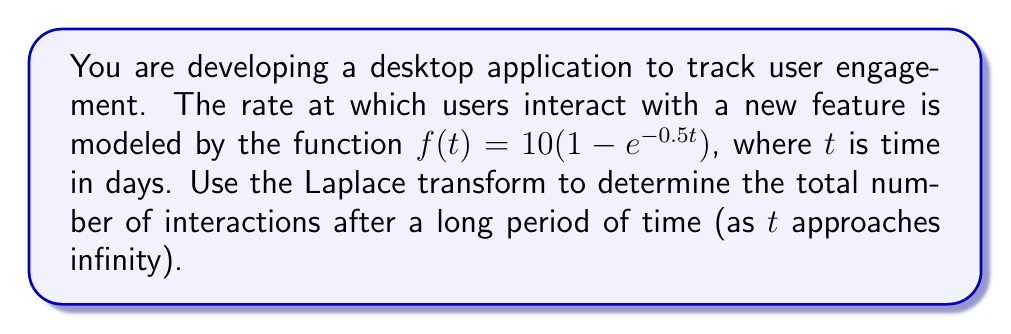Teach me how to tackle this problem. To solve this problem, we'll follow these steps:

1) First, let's recall the Laplace transform of $f(t)$:

   $\mathcal{L}\{f(t)\} = F(s) = \int_0^\infty f(t)e^{-st}dt$

2) We need to find the Laplace transform of our function:

   $f(t) = 10(1 - e^{-0.5t})$

3) We can split this into two parts:

   $\mathcal{L}\{10\} - \mathcal{L}\{10e^{-0.5t}\}$

4) The Laplace transform of a constant $a$ is $\frac{a}{s}$, so:

   $\mathcal{L}\{10\} = \frac{10}{s}$

5) For the second part, we can use the Laplace transform of $e^{-at}$, which is $\frac{1}{s+a}$:

   $\mathcal{L}\{10e^{-0.5t}\} = \frac{10}{s+0.5}$

6) Combining these:

   $F(s) = \frac{10}{s} - \frac{10}{s+0.5}$

7) To find the total number of interactions as $t$ approaches infinity, we can use the Final Value Theorem:

   $\lim_{t \to \infty} f(t) = \lim_{s \to 0} sF(s)$

8) Let's apply this:

   $\lim_{s \to 0} s(\frac{10}{s} - \frac{10}{s+0.5})$

9) Simplify:

   $\lim_{s \to 0} (10 - \frac{10s}{s+0.5})$

10) As $s$ approaches 0, this becomes:

    $10 - \frac{10 \cdot 0}{0+0.5} = 10 - 0 = 10$

Therefore, the total number of interactions after a long period of time is 10.
Answer: 10 interactions 